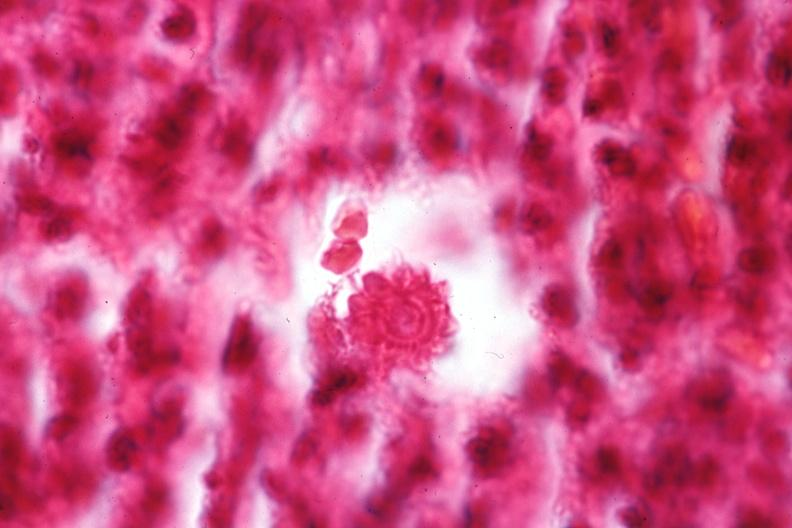s bone, mandible present?
Answer the question using a single word or phrase. No 